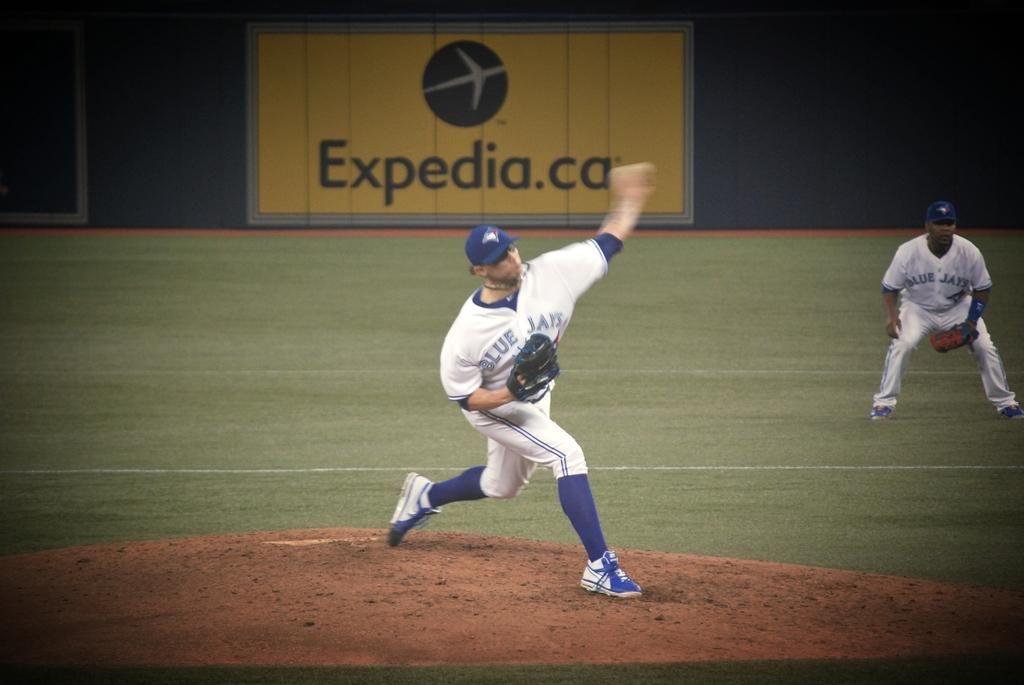<image>
Describe the image concisely. The Blue Jays pitcher throws the ball in front of a expedia.ca sign. 